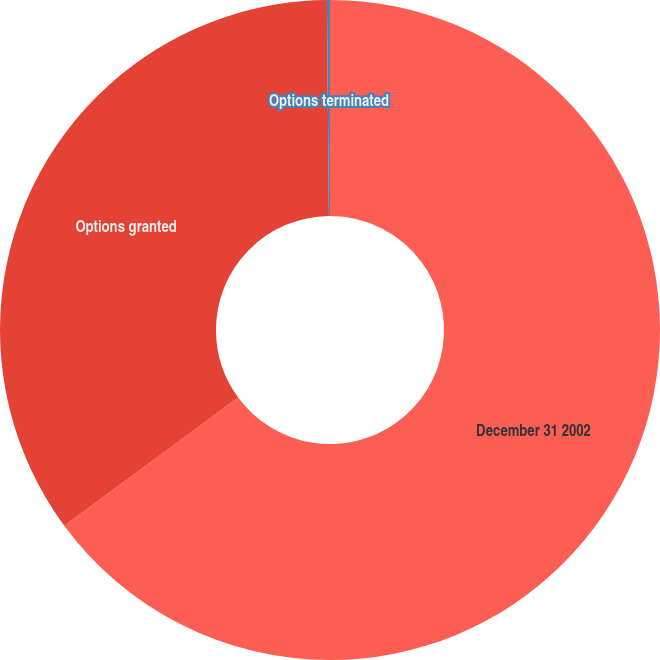<chart> <loc_0><loc_0><loc_500><loc_500><pie_chart><fcel>December 31 2002<fcel>Options granted<fcel>Options terminated<nl><fcel>64.9%<fcel>34.95%<fcel>0.15%<nl></chart> 